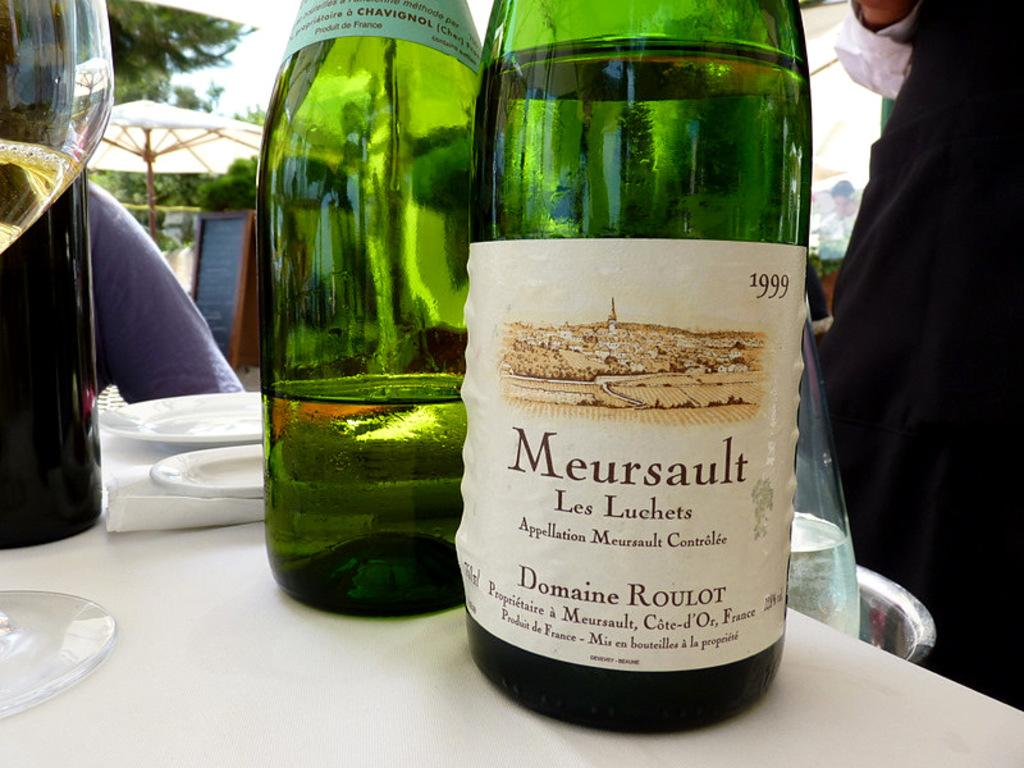Provide a one-sentence caption for the provided image. A bottle of alcohol is labeled with the Meursault name. 